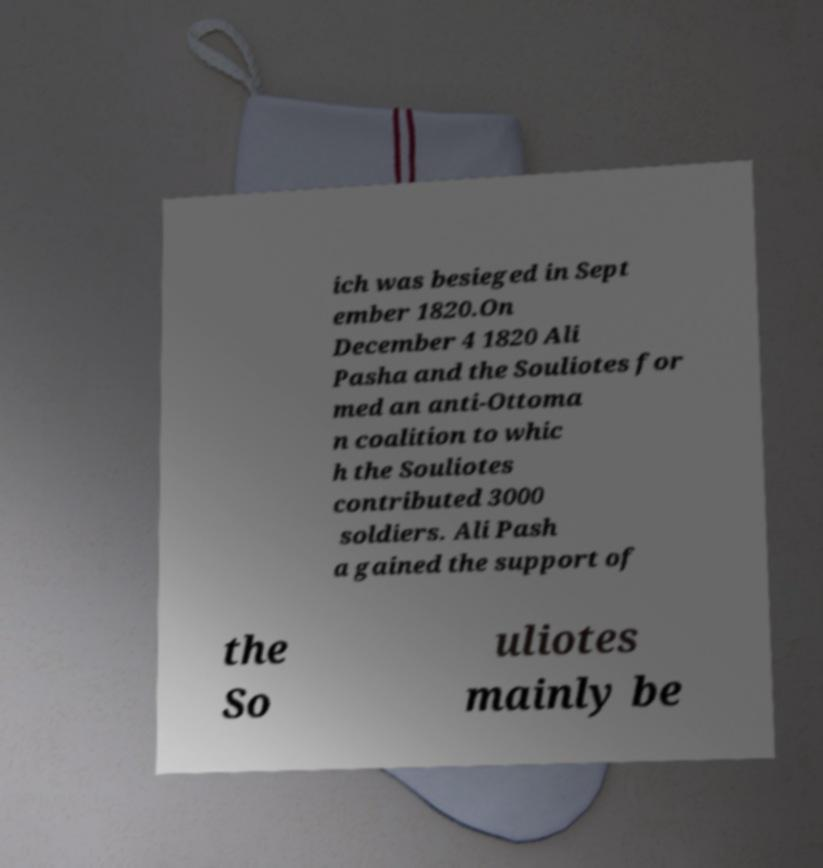Can you accurately transcribe the text from the provided image for me? ich was besieged in Sept ember 1820.On December 4 1820 Ali Pasha and the Souliotes for med an anti-Ottoma n coalition to whic h the Souliotes contributed 3000 soldiers. Ali Pash a gained the support of the So uliotes mainly be 